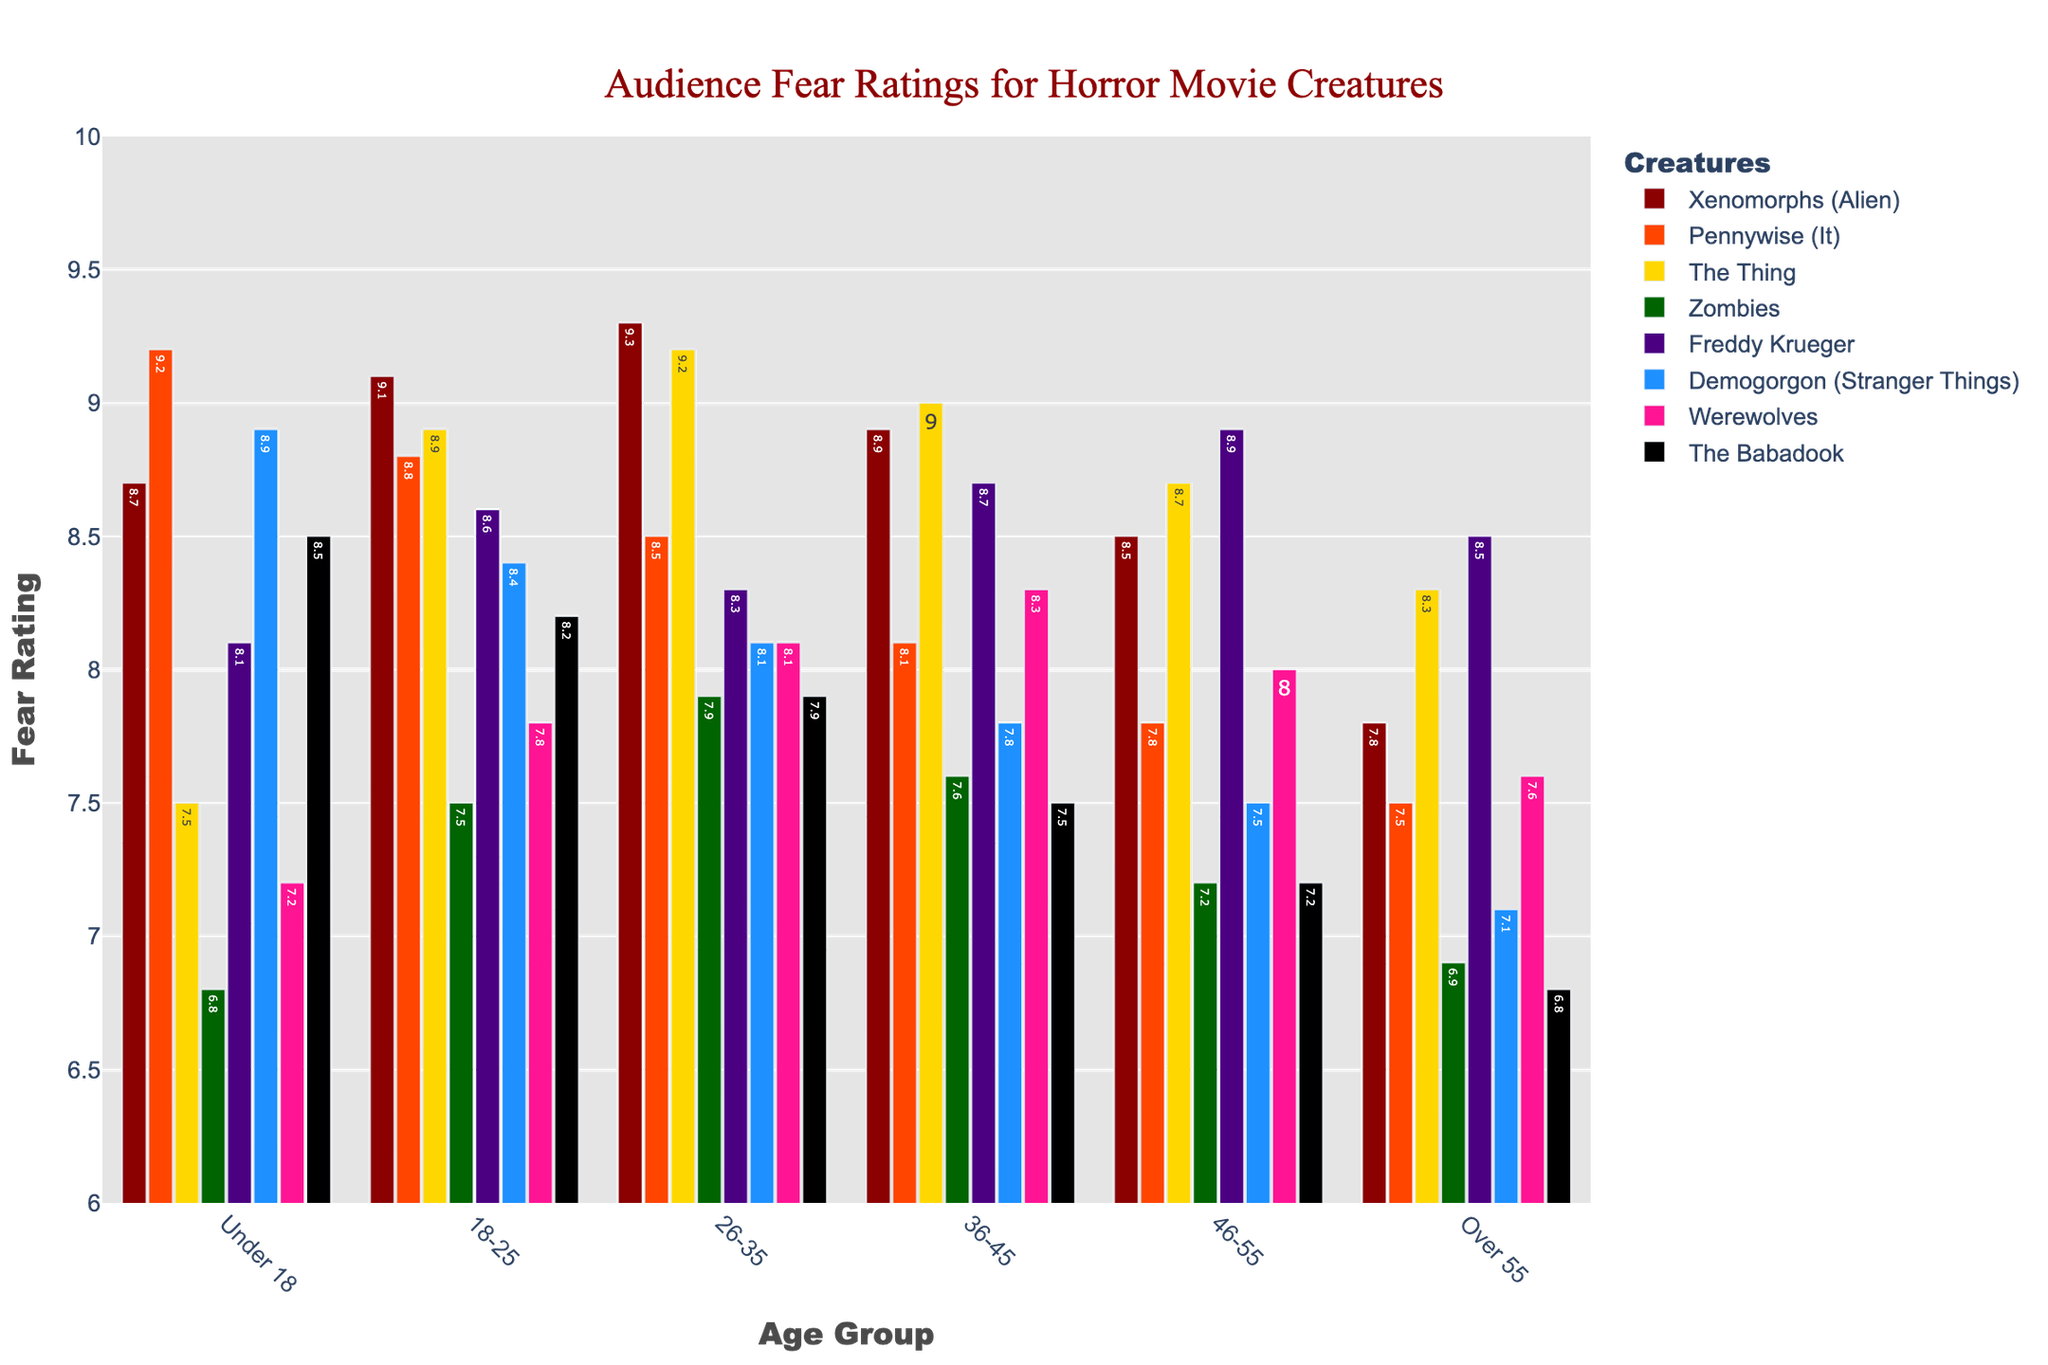Which age group finds Freddy Krueger the scariest? Look at the bar heights for Freddy Krueger across different age groups and find which is the tallest.
Answer: 46-55 Which creature has the highest fear rating among the 18-25 age group? Observe the bar heights for the 18-25 age group and identify the creature with the tallest bar.
Answer: Xenomorphs (Alien) Compare the fear ratings of The Thing for the under 18 and over 55 age groups. Which group finds it scarier? Compare the height of the bar for The Thing in both the under 18 and over 55 age groups to find which is higher.
Answer: Under 18 What is the average fear rating for the Demogorgon (Stranger Things) across all age groups? Sum the ratings for the Demogorgon (Stranger Things) across all age groups and divide by the number of groups (6).
Answer: (8.9 + 8.4 + 8.1 + 7.8 + 7.5 + 7.1) / 6 = 8 Which creature has the lowest fear rating in the 26-35 age group? Look at the bar heights for each creature in the 26-35 age group and find the shortest bar.
Answer: The Babadook How much higher is the fear rating of Pennywise (It) compared to Zombies in the under 18 age group? Subtract the fear rating of Zombies from the rating of Pennywise (It) in the under 18 age group.
Answer: 9.2 - 6.8 = 2.4 Which creatures have a fear rating greater than 8 across all age groups? Identify the creatures that have a bar taller than the height representing a rating of 8 across every age group.
Answer: Xenomorphs (Alien), Freddy Krueger What is the difference in fear ratings for Werewolves between the under 18 and 26-35 age groups? Subtract the fear rating of Werewolves in the under 18 group from the rating in the 26-35 group.
Answer: 8.1 - 7.2 = 0.9 Compare the fear ratings of zombies in the under 18 and 18-25 age groups. Which age group finds zombies scarier? Compare the height of bars representing the fear ratings of zombies in the under 18 and 18-25 age groups.
Answer: 18-25 Which age group finds The Babadook the least scary? Look for the shortest bar representing The Babadook across all age groups.
Answer: Over 55 